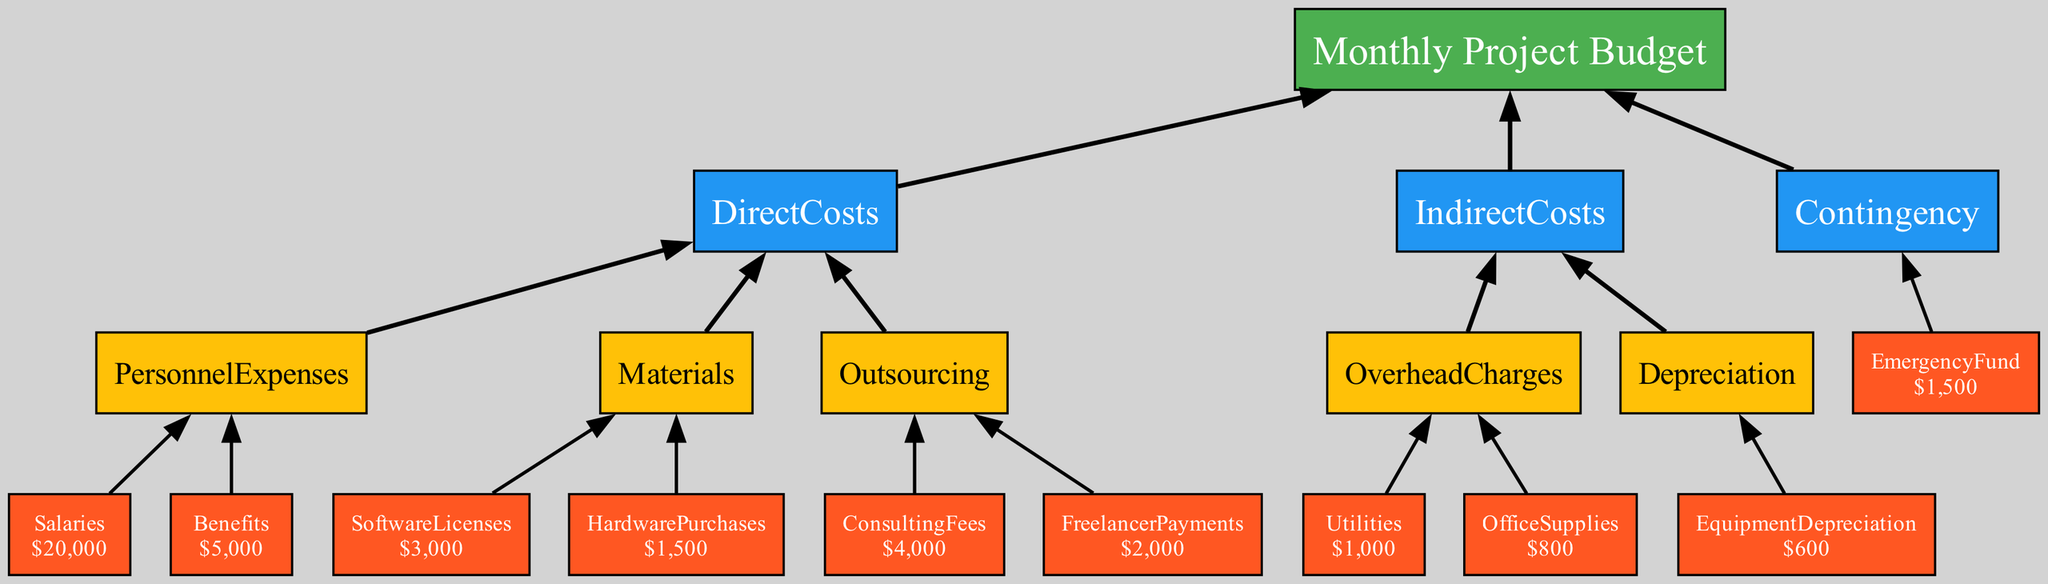What is the total personnel expense? To find the total personnel expense, sum the values of salaries and benefits. Salaries are 20000 and benefits are 5000. Therefore, total personnel expense = 20000 + 5000 = 25000.
Answer: 25000 How many main cost categories are there? The main cost categories in the diagram are Direct Costs, Indirect Costs, and Contingency, totaling three categories.
Answer: 3 What is the total amount allocated for outsourcing? The total amount allocated for outsourcing is found by adding consulting fees and freelancer payments. Consulting fees are 4000 and freelancer payments are 2000. Therefore, total outsourcing = 4000 + 2000 = 6000.
Answer: 6000 Which category does equipment depreciation belong to? Equipment depreciation falls under Indirect Costs as part of the Depreciation sub-category in the diagram.
Answer: Indirect Costs What is the sum of the overhead charges? To find the sum of overhead charges, add the values of utilities and office supplies. Utilities are 1000 and office supplies are 800. Hence, total overhead charges = 1000 + 800 = 1800.
Answer: 1800 What is the total budget for materials? The total budget for materials includes software licenses and hardware purchases. Software licenses are 3000 and hardware purchases are 1500. Therefore, total materials = 3000 + 1500 = 4500.
Answer: 4500 How does the contingency fund contribute to the overall budget? The contingency fund is represented as a separate category and provides an amount of 1500 which is additional to both direct and indirect costs, contributing to managing unforeseen expenses.
Answer: 1500 What is the relationship between personnel expenses and direct costs? Personnel expenses are a subset or component of the Direct Costs category, indicating that they are part of the total direct costs allocated for the project.
Answer: Subset What is the value of freelancer payments? The value of freelancer payments is explicitly shown as 2000 in the Outsourcing section of the diagram.
Answer: 2000 